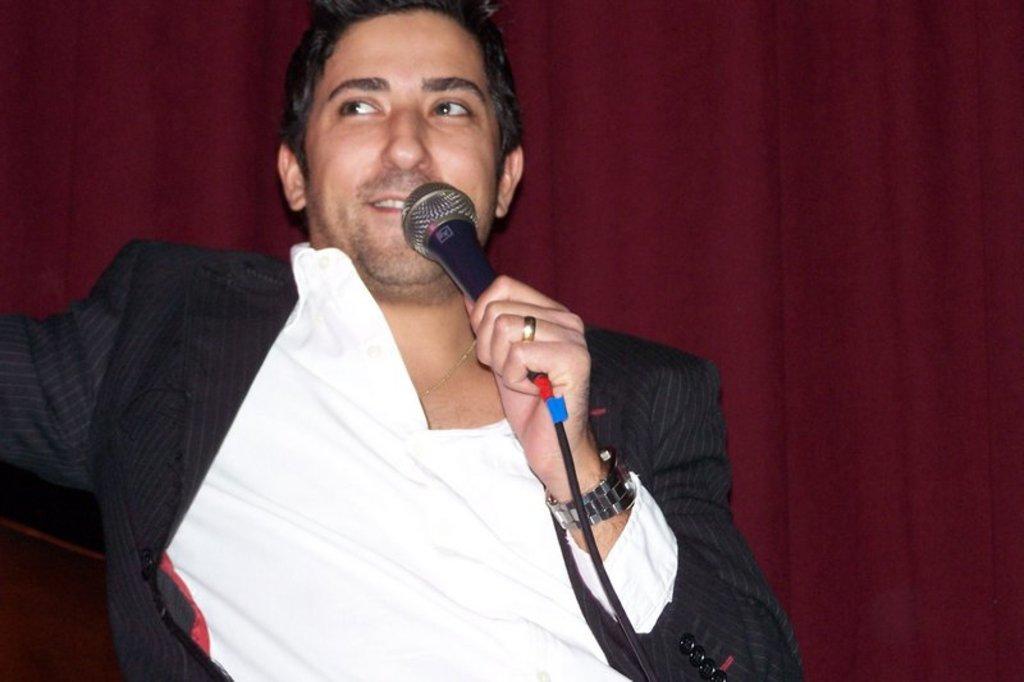Describe this image in one or two sentences. This is the picture of a man in black blazer holding a microphone. Background of the man is a curtain. 